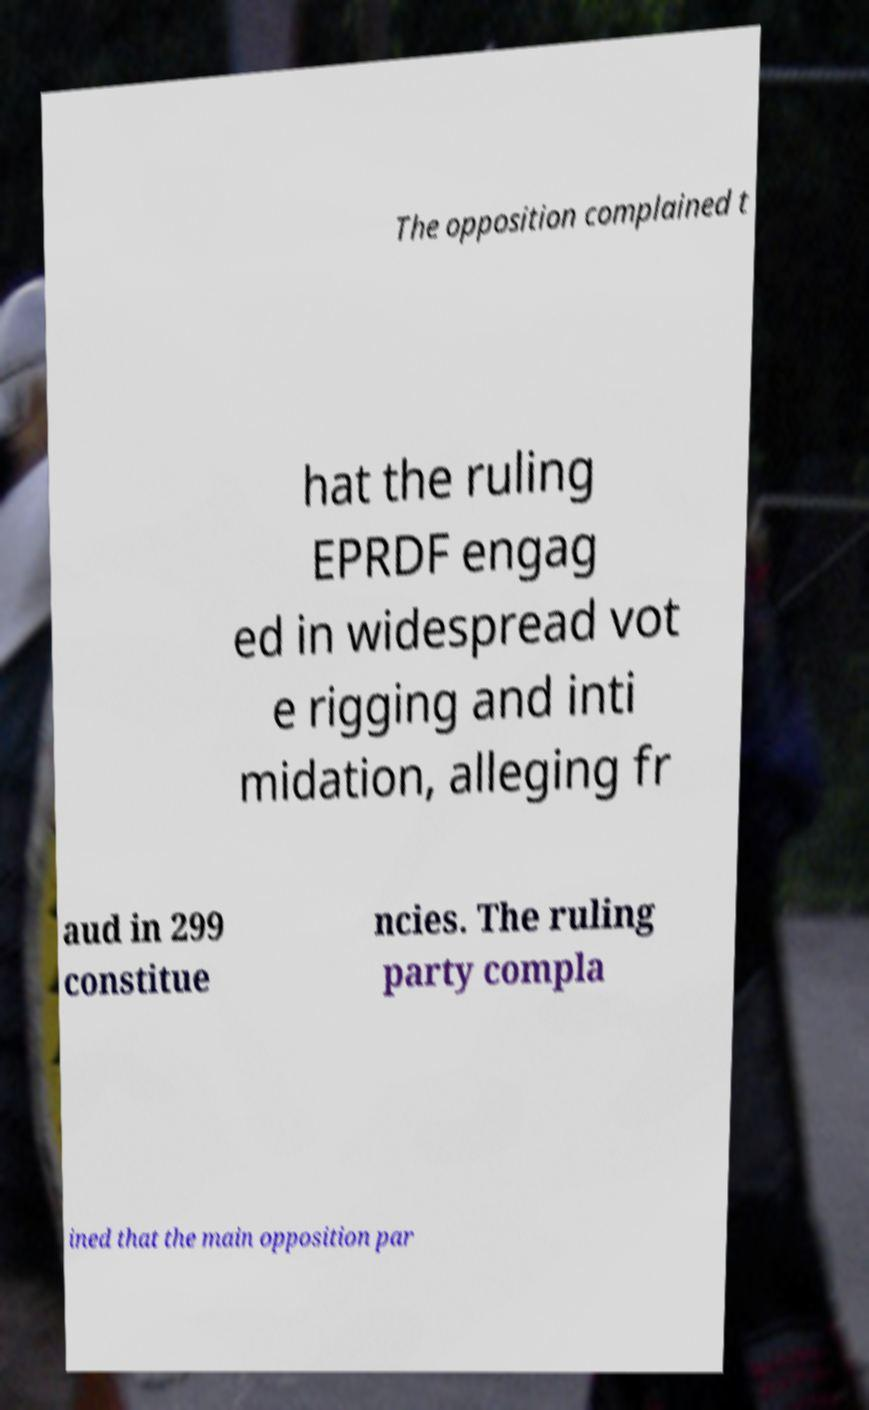What messages or text are displayed in this image? I need them in a readable, typed format. The opposition complained t hat the ruling EPRDF engag ed in widespread vot e rigging and inti midation, alleging fr aud in 299 constitue ncies. The ruling party compla ined that the main opposition par 